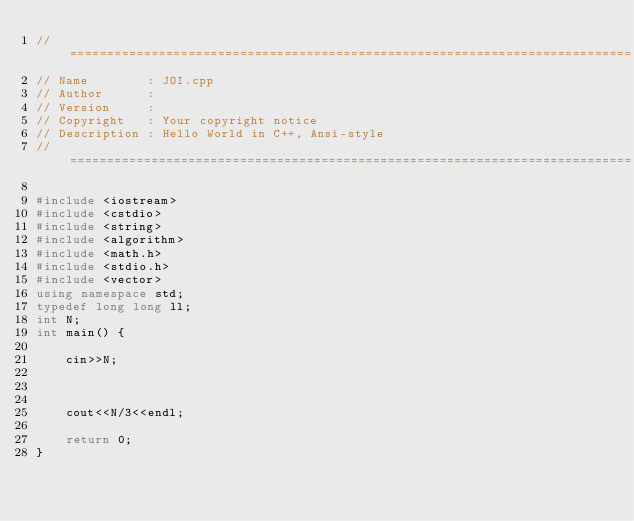Convert code to text. <code><loc_0><loc_0><loc_500><loc_500><_C++_>//============================================================================
// Name        : JOI.cpp
// Author      :
// Version     :
// Copyright   : Your copyright notice
// Description : Hello World in C++, Ansi-style
//============================================================================

#include <iostream>
#include <cstdio>
#include <string>
#include <algorithm>
#include <math.h>
#include <stdio.h>
#include <vector>
using namespace std;
typedef long long ll;
int N;
int main() {

	cin>>N;



	cout<<N/3<<endl;

 	return 0;
}
</code> 